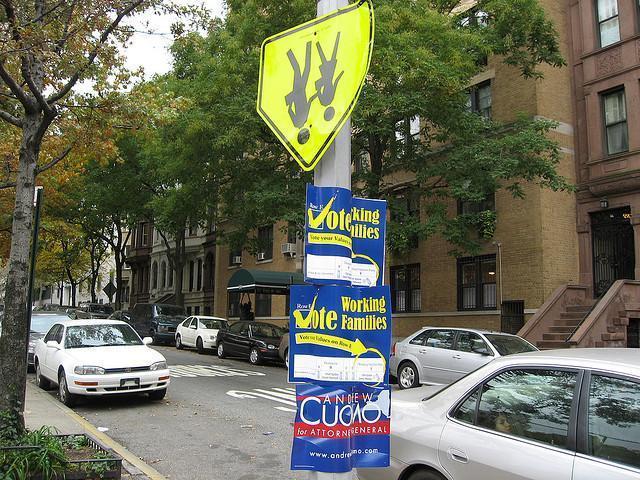How many cars are there?
Give a very brief answer. 5. 